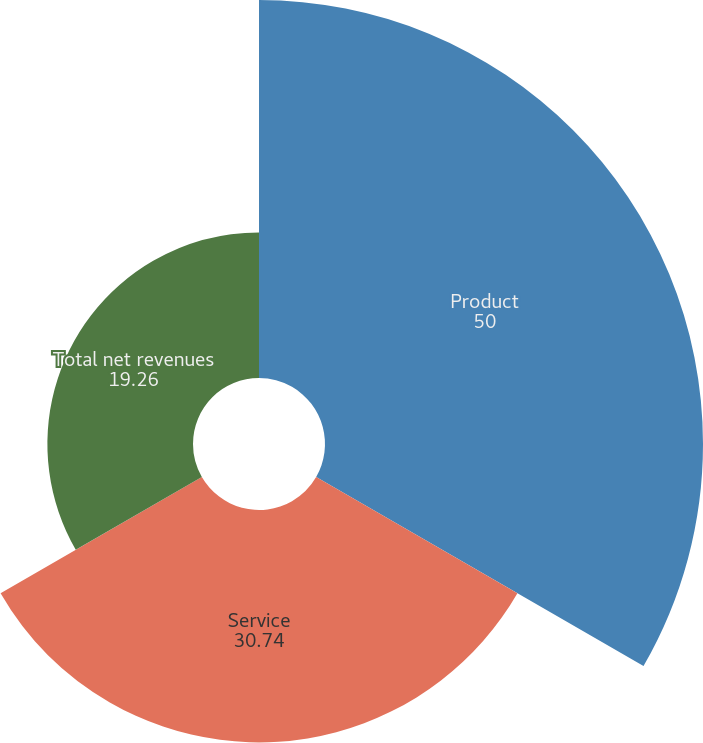Convert chart. <chart><loc_0><loc_0><loc_500><loc_500><pie_chart><fcel>Product<fcel>Service<fcel>Total net revenues<nl><fcel>50.0%<fcel>30.74%<fcel>19.26%<nl></chart> 